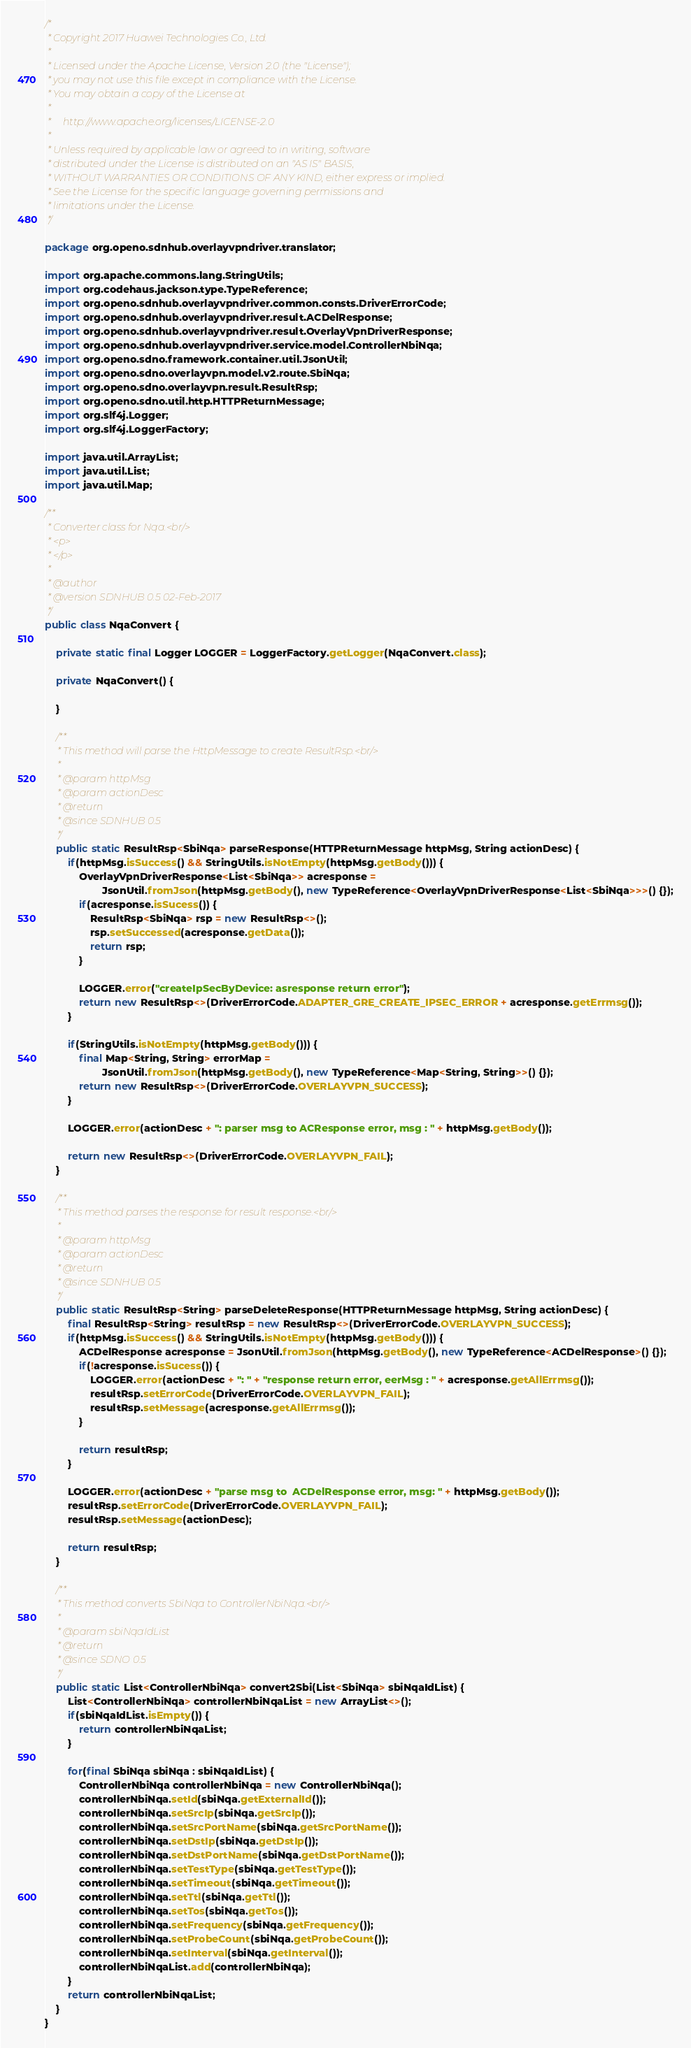<code> <loc_0><loc_0><loc_500><loc_500><_Java_>/*
 * Copyright 2017 Huawei Technologies Co., Ltd.
 *
 * Licensed under the Apache License, Version 2.0 (the "License");
 * you may not use this file except in compliance with the License.
 * You may obtain a copy of the License at
 *
 *     http://www.apache.org/licenses/LICENSE-2.0
 *
 * Unless required by applicable law or agreed to in writing, software
 * distributed under the License is distributed on an "AS IS" BASIS,
 * WITHOUT WARRANTIES OR CONDITIONS OF ANY KIND, either express or implied.
 * See the License for the specific language governing permissions and
 * limitations under the License.
 */

package org.openo.sdnhub.overlayvpndriver.translator;

import org.apache.commons.lang.StringUtils;
import org.codehaus.jackson.type.TypeReference;
import org.openo.sdnhub.overlayvpndriver.common.consts.DriverErrorCode;
import org.openo.sdnhub.overlayvpndriver.result.ACDelResponse;
import org.openo.sdnhub.overlayvpndriver.result.OverlayVpnDriverResponse;
import org.openo.sdnhub.overlayvpndriver.service.model.ControllerNbiNqa;
import org.openo.sdno.framework.container.util.JsonUtil;
import org.openo.sdno.overlayvpn.model.v2.route.SbiNqa;
import org.openo.sdno.overlayvpn.result.ResultRsp;
import org.openo.sdno.util.http.HTTPReturnMessage;
import org.slf4j.Logger;
import org.slf4j.LoggerFactory;

import java.util.ArrayList;
import java.util.List;
import java.util.Map;

/**
 * Converter class for Nqa.<br/>
 * <p>
 * </p>
 *
 * @author
 * @version SDNHUB 0.5 02-Feb-2017
 */
public class NqaConvert {

    private static final Logger LOGGER = LoggerFactory.getLogger(NqaConvert.class);

    private NqaConvert() {

    }

    /**
     * This method will parse the HttpMessage to create ResultRsp.<br/>
     *
     * @param httpMsg
     * @param actionDesc
     * @return
     * @since SDNHUB 0.5
     */
    public static ResultRsp<SbiNqa> parseResponse(HTTPReturnMessage httpMsg, String actionDesc) {
        if(httpMsg.isSuccess() && StringUtils.isNotEmpty(httpMsg.getBody())) {
            OverlayVpnDriverResponse<List<SbiNqa>> acresponse =
                    JsonUtil.fromJson(httpMsg.getBody(), new TypeReference<OverlayVpnDriverResponse<List<SbiNqa>>>() {});
            if(acresponse.isSucess()) {
                ResultRsp<SbiNqa> rsp = new ResultRsp<>();
                rsp.setSuccessed(acresponse.getData());
                return rsp;
            }

            LOGGER.error("createIpSecByDevice: asresponse return error");
            return new ResultRsp<>(DriverErrorCode.ADAPTER_GRE_CREATE_IPSEC_ERROR + acresponse.getErrmsg());
        }

        if(StringUtils.isNotEmpty(httpMsg.getBody())) {
            final Map<String, String> errorMap =
                    JsonUtil.fromJson(httpMsg.getBody(), new TypeReference<Map<String, String>>() {});
            return new ResultRsp<>(DriverErrorCode.OVERLAYVPN_SUCCESS);
        }

        LOGGER.error(actionDesc + ": parser msg to ACResponse error, msg : " + httpMsg.getBody());

        return new ResultRsp<>(DriverErrorCode.OVERLAYVPN_FAIL);
    }

    /**
     * This method parses the response for result response.<br/>
     *
     * @param httpMsg
     * @param actionDesc
     * @return
     * @since SDNHUB 0.5
     */
    public static ResultRsp<String> parseDeleteResponse(HTTPReturnMessage httpMsg, String actionDesc) {
        final ResultRsp<String> resultRsp = new ResultRsp<>(DriverErrorCode.OVERLAYVPN_SUCCESS);
        if(httpMsg.isSuccess() && StringUtils.isNotEmpty(httpMsg.getBody())) {
            ACDelResponse acresponse = JsonUtil.fromJson(httpMsg.getBody(), new TypeReference<ACDelResponse>() {});
            if(!acresponse.isSucess()) {
                LOGGER.error(actionDesc + ": " + "response return error, eerMsg : " + acresponse.getAllErrmsg());
                resultRsp.setErrorCode(DriverErrorCode.OVERLAYVPN_FAIL);
                resultRsp.setMessage(acresponse.getAllErrmsg());
            }

            return resultRsp;
        }

        LOGGER.error(actionDesc + "parse msg to  ACDelResponse error, msg: " + httpMsg.getBody());
        resultRsp.setErrorCode(DriverErrorCode.OVERLAYVPN_FAIL);
        resultRsp.setMessage(actionDesc);

        return resultRsp;
    }

    /**
     * This method converts SbiNqa to ControllerNbiNqa.<br/>
     *
     * @param sbiNqaIdList
     * @return
     * @since SDNO 0.5
     */
    public static List<ControllerNbiNqa> convert2Sbi(List<SbiNqa> sbiNqaIdList) {
        List<ControllerNbiNqa> controllerNbiNqaList = new ArrayList<>();
        if(sbiNqaIdList.isEmpty()) {
            return controllerNbiNqaList;
        }

        for(final SbiNqa sbiNqa : sbiNqaIdList) {
            ControllerNbiNqa controllerNbiNqa = new ControllerNbiNqa();
            controllerNbiNqa.setId(sbiNqa.getExternalId());
            controllerNbiNqa.setSrcIp(sbiNqa.getSrcIp());
            controllerNbiNqa.setSrcPortName(sbiNqa.getSrcPortName());
            controllerNbiNqa.setDstIp(sbiNqa.getDstIp());
            controllerNbiNqa.setDstPortName(sbiNqa.getDstPortName());
            controllerNbiNqa.setTestType(sbiNqa.getTestType());
            controllerNbiNqa.setTimeout(sbiNqa.getTimeout());
            controllerNbiNqa.setTtl(sbiNqa.getTtl());
            controllerNbiNqa.setTos(sbiNqa.getTos());
            controllerNbiNqa.setFrequency(sbiNqa.getFrequency());
            controllerNbiNqa.setProbeCount(sbiNqa.getProbeCount());
            controllerNbiNqa.setInterval(sbiNqa.getInterval());
            controllerNbiNqaList.add(controllerNbiNqa);
        }
        return controllerNbiNqaList;
    }
}
</code> 